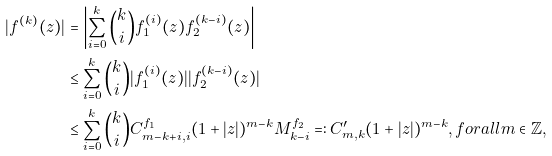<formula> <loc_0><loc_0><loc_500><loc_500>| f ^ { ( k ) } ( z ) | & = \left | \sum _ { i = 0 } ^ { k } \binom { k } { i } f _ { 1 } ^ { ( i ) } ( z ) f _ { 2 } ^ { ( k - i ) } ( z ) \right | \\ & \leq \sum _ { i = 0 } ^ { k } \binom { k } { i } | f _ { 1 } ^ { ( i ) } ( z ) | | f _ { 2 } ^ { ( k - i ) } ( z ) | \\ & \leq \sum _ { i = 0 } ^ { k } \binom { k } { i } C ^ { f _ { 1 } } _ { m - k + i , i } ( 1 + | z | ) ^ { m - k } M ^ { f _ { 2 } } _ { k - i } = \colon C ^ { \prime } _ { m , k } ( 1 + | z | ) ^ { m - k } , f o r a l l m \in \mathbb { Z } ,</formula> 